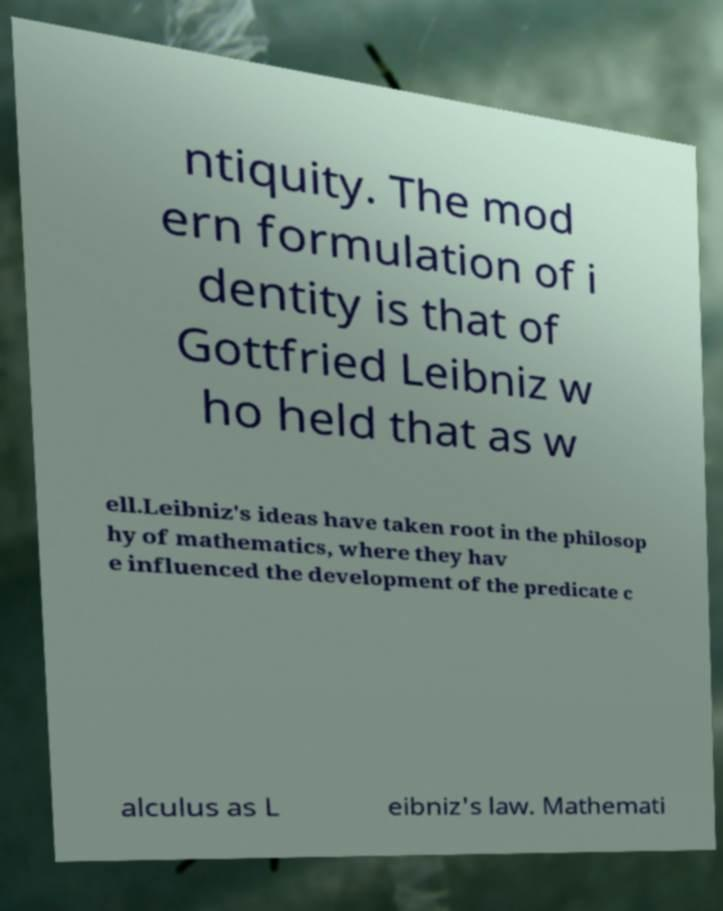Could you extract and type out the text from this image? ntiquity. The mod ern formulation of i dentity is that of Gottfried Leibniz w ho held that as w ell.Leibniz's ideas have taken root in the philosop hy of mathematics, where they hav e influenced the development of the predicate c alculus as L eibniz's law. Mathemati 